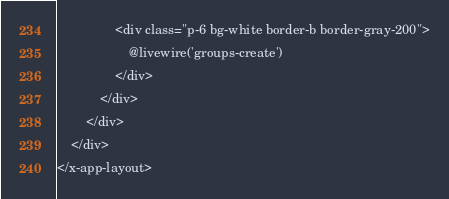Convert code to text. <code><loc_0><loc_0><loc_500><loc_500><_PHP_>                <div class="p-6 bg-white border-b border-gray-200">
                    @livewire('groups-create')
                </div>
            </div>
        </div>
    </div>
</x-app-layout>



</code> 